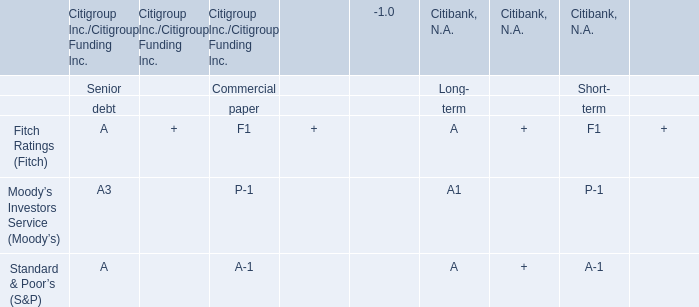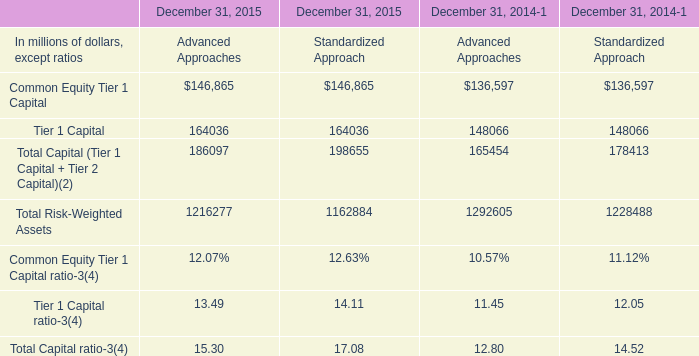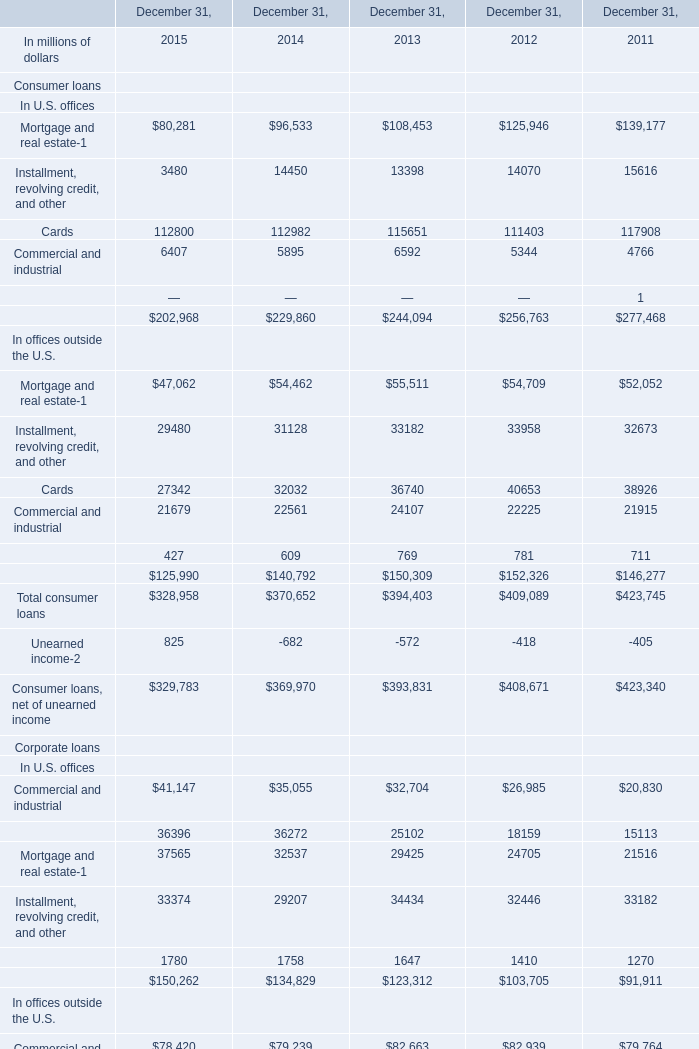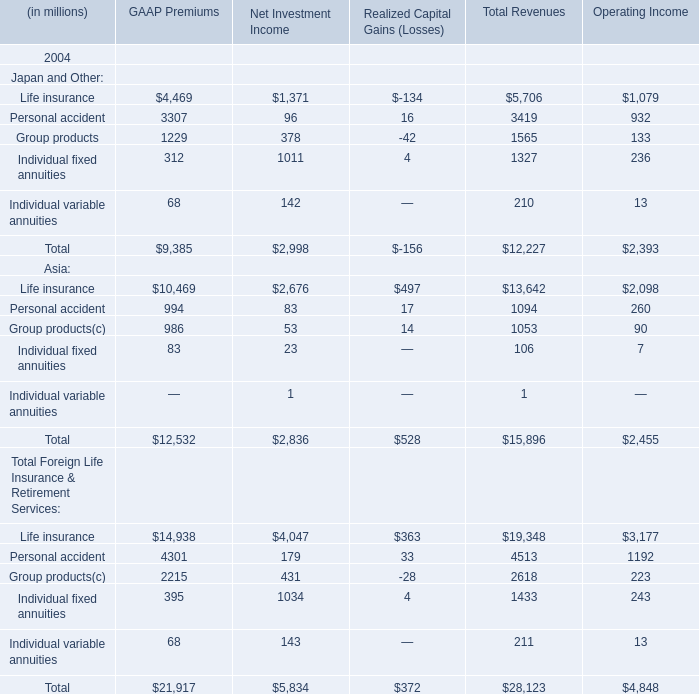How many years does Tier 1 Capital ratio stay higher than Total Capital ratio? 
Answer: 0. 